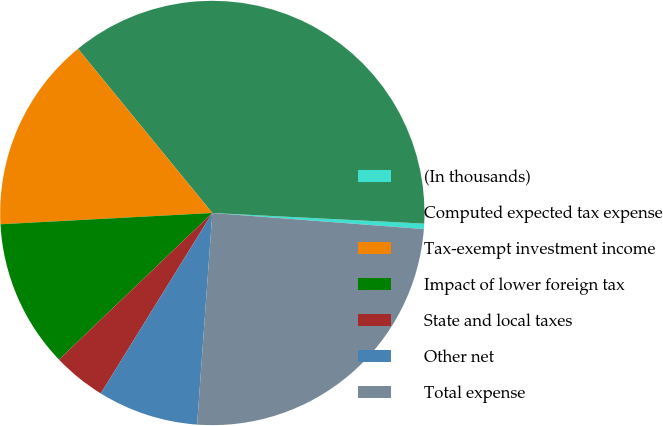Convert chart. <chart><loc_0><loc_0><loc_500><loc_500><pie_chart><fcel>(In thousands)<fcel>Computed expected tax expense<fcel>Tax-exempt investment income<fcel>Impact of lower foreign tax<fcel>State and local taxes<fcel>Other net<fcel>Total expense<nl><fcel>0.41%<fcel>36.71%<fcel>14.93%<fcel>11.3%<fcel>4.04%<fcel>7.67%<fcel>24.93%<nl></chart> 